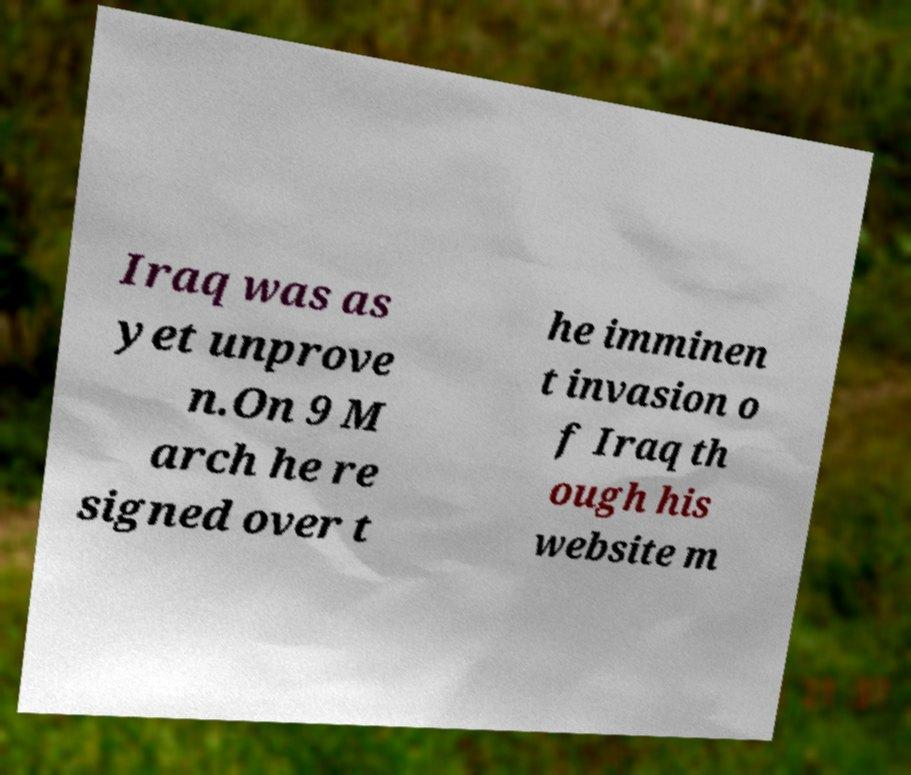Could you extract and type out the text from this image? Iraq was as yet unprove n.On 9 M arch he re signed over t he imminen t invasion o f Iraq th ough his website m 